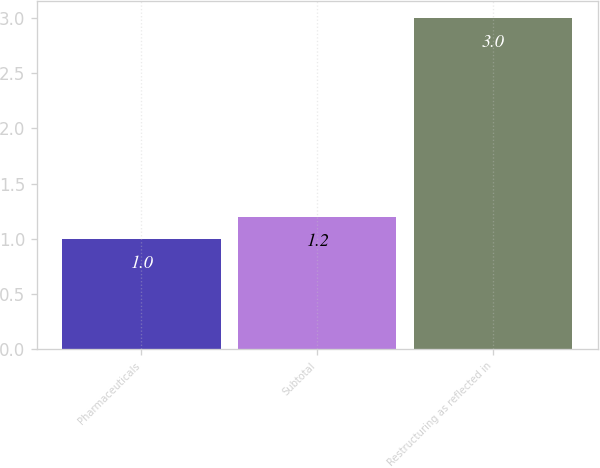<chart> <loc_0><loc_0><loc_500><loc_500><bar_chart><fcel>Pharmaceuticals<fcel>Subtotal<fcel>Restructuring as reflected in<nl><fcel>1<fcel>1.2<fcel>3<nl></chart> 